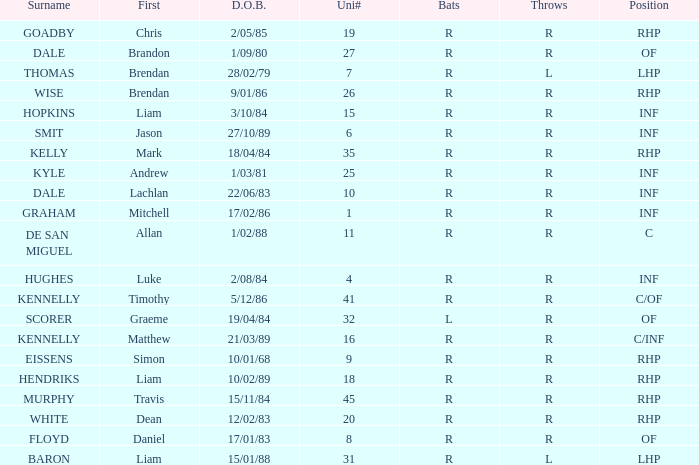Which batter has the last name Graham? R. 